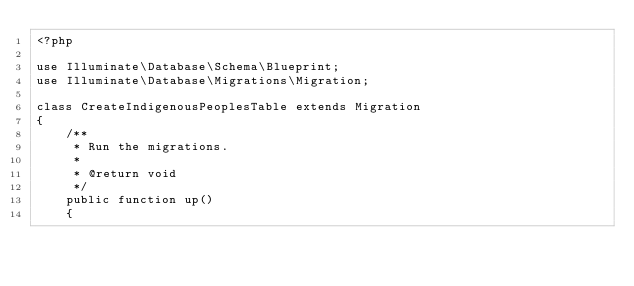<code> <loc_0><loc_0><loc_500><loc_500><_PHP_><?php

use Illuminate\Database\Schema\Blueprint;
use Illuminate\Database\Migrations\Migration;

class CreateIndigenousPeoplesTable extends Migration
{
    /**
     * Run the migrations.
     *
     * @return void
     */
    public function up()
    {</code> 